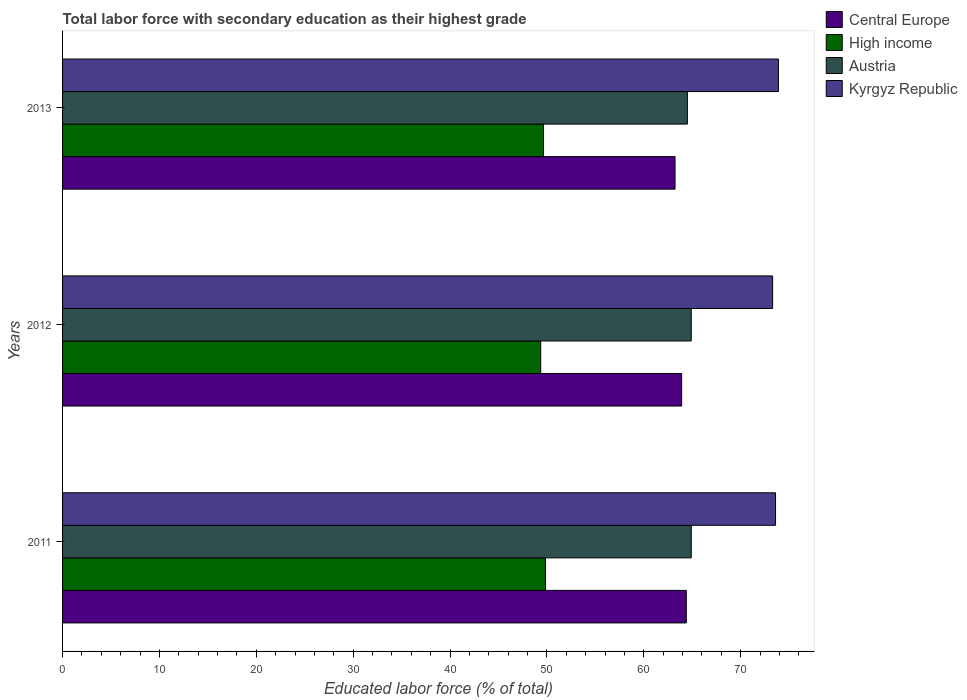How many different coloured bars are there?
Offer a very short reply. 4. How many groups of bars are there?
Make the answer very short. 3. How many bars are there on the 1st tick from the bottom?
Offer a terse response. 4. What is the label of the 3rd group of bars from the top?
Your response must be concise. 2011. What is the percentage of total labor force with primary education in High income in 2012?
Provide a succinct answer. 49.36. Across all years, what is the maximum percentage of total labor force with primary education in Austria?
Keep it short and to the point. 64.9. Across all years, what is the minimum percentage of total labor force with primary education in Kyrgyz Republic?
Ensure brevity in your answer.  73.3. In which year was the percentage of total labor force with primary education in Central Europe maximum?
Offer a very short reply. 2011. What is the total percentage of total labor force with primary education in Kyrgyz Republic in the graph?
Give a very brief answer. 220.8. What is the difference between the percentage of total labor force with primary education in Kyrgyz Republic in 2012 and that in 2013?
Make the answer very short. -0.6. What is the difference between the percentage of total labor force with primary education in Kyrgyz Republic in 2011 and the percentage of total labor force with primary education in Central Europe in 2013?
Your answer should be compact. 10.37. What is the average percentage of total labor force with primary education in Austria per year?
Your answer should be very brief. 64.77. In the year 2011, what is the difference between the percentage of total labor force with primary education in Austria and percentage of total labor force with primary education in Central Europe?
Provide a short and direct response. 0.51. What is the ratio of the percentage of total labor force with primary education in High income in 2011 to that in 2012?
Your answer should be compact. 1.01. Is the percentage of total labor force with primary education in Kyrgyz Republic in 2012 less than that in 2013?
Your answer should be compact. Yes. Is the difference between the percentage of total labor force with primary education in Austria in 2011 and 2012 greater than the difference between the percentage of total labor force with primary education in Central Europe in 2011 and 2012?
Keep it short and to the point. No. What is the difference between the highest and the lowest percentage of total labor force with primary education in Austria?
Provide a succinct answer. 0.4. In how many years, is the percentage of total labor force with primary education in Austria greater than the average percentage of total labor force with primary education in Austria taken over all years?
Provide a succinct answer. 2. Is the sum of the percentage of total labor force with primary education in Austria in 2011 and 2012 greater than the maximum percentage of total labor force with primary education in Kyrgyz Republic across all years?
Offer a very short reply. Yes. Is it the case that in every year, the sum of the percentage of total labor force with primary education in Austria and percentage of total labor force with primary education in Kyrgyz Republic is greater than the sum of percentage of total labor force with primary education in Central Europe and percentage of total labor force with primary education in High income?
Give a very brief answer. Yes. What does the 3rd bar from the top in 2013 represents?
Ensure brevity in your answer.  High income. What does the 3rd bar from the bottom in 2013 represents?
Your answer should be compact. Austria. Is it the case that in every year, the sum of the percentage of total labor force with primary education in High income and percentage of total labor force with primary education in Kyrgyz Republic is greater than the percentage of total labor force with primary education in Central Europe?
Offer a terse response. Yes. How many bars are there?
Offer a terse response. 12. Are all the bars in the graph horizontal?
Your answer should be compact. Yes. Are the values on the major ticks of X-axis written in scientific E-notation?
Your answer should be compact. No. Does the graph contain any zero values?
Offer a terse response. No. Does the graph contain grids?
Your response must be concise. No. Where does the legend appear in the graph?
Keep it short and to the point. Top right. What is the title of the graph?
Make the answer very short. Total labor force with secondary education as their highest grade. Does "Sub-Saharan Africa (developing only)" appear as one of the legend labels in the graph?
Offer a terse response. No. What is the label or title of the X-axis?
Offer a very short reply. Educated labor force (% of total). What is the label or title of the Y-axis?
Offer a very short reply. Years. What is the Educated labor force (% of total) in Central Europe in 2011?
Keep it short and to the point. 64.39. What is the Educated labor force (% of total) of High income in 2011?
Your response must be concise. 49.85. What is the Educated labor force (% of total) of Austria in 2011?
Your answer should be very brief. 64.9. What is the Educated labor force (% of total) of Kyrgyz Republic in 2011?
Ensure brevity in your answer.  73.6. What is the Educated labor force (% of total) in Central Europe in 2012?
Provide a short and direct response. 63.91. What is the Educated labor force (% of total) in High income in 2012?
Keep it short and to the point. 49.36. What is the Educated labor force (% of total) in Austria in 2012?
Provide a short and direct response. 64.9. What is the Educated labor force (% of total) of Kyrgyz Republic in 2012?
Offer a very short reply. 73.3. What is the Educated labor force (% of total) in Central Europe in 2013?
Your answer should be compact. 63.23. What is the Educated labor force (% of total) of High income in 2013?
Give a very brief answer. 49.65. What is the Educated labor force (% of total) in Austria in 2013?
Provide a succinct answer. 64.5. What is the Educated labor force (% of total) of Kyrgyz Republic in 2013?
Offer a terse response. 73.9. Across all years, what is the maximum Educated labor force (% of total) of Central Europe?
Your answer should be very brief. 64.39. Across all years, what is the maximum Educated labor force (% of total) in High income?
Give a very brief answer. 49.85. Across all years, what is the maximum Educated labor force (% of total) in Austria?
Your response must be concise. 64.9. Across all years, what is the maximum Educated labor force (% of total) of Kyrgyz Republic?
Ensure brevity in your answer.  73.9. Across all years, what is the minimum Educated labor force (% of total) of Central Europe?
Provide a succinct answer. 63.23. Across all years, what is the minimum Educated labor force (% of total) in High income?
Give a very brief answer. 49.36. Across all years, what is the minimum Educated labor force (% of total) of Austria?
Offer a terse response. 64.5. Across all years, what is the minimum Educated labor force (% of total) of Kyrgyz Republic?
Offer a terse response. 73.3. What is the total Educated labor force (% of total) in Central Europe in the graph?
Provide a succinct answer. 191.52. What is the total Educated labor force (% of total) in High income in the graph?
Provide a short and direct response. 148.86. What is the total Educated labor force (% of total) of Austria in the graph?
Provide a short and direct response. 194.3. What is the total Educated labor force (% of total) of Kyrgyz Republic in the graph?
Provide a short and direct response. 220.8. What is the difference between the Educated labor force (% of total) in Central Europe in 2011 and that in 2012?
Make the answer very short. 0.48. What is the difference between the Educated labor force (% of total) in High income in 2011 and that in 2012?
Offer a very short reply. 0.49. What is the difference between the Educated labor force (% of total) in Austria in 2011 and that in 2012?
Your response must be concise. 0. What is the difference between the Educated labor force (% of total) of Kyrgyz Republic in 2011 and that in 2012?
Provide a succinct answer. 0.3. What is the difference between the Educated labor force (% of total) of Central Europe in 2011 and that in 2013?
Keep it short and to the point. 1.16. What is the difference between the Educated labor force (% of total) in High income in 2011 and that in 2013?
Provide a succinct answer. 0.2. What is the difference between the Educated labor force (% of total) of Kyrgyz Republic in 2011 and that in 2013?
Your answer should be very brief. -0.3. What is the difference between the Educated labor force (% of total) of Central Europe in 2012 and that in 2013?
Your response must be concise. 0.68. What is the difference between the Educated labor force (% of total) of High income in 2012 and that in 2013?
Provide a short and direct response. -0.29. What is the difference between the Educated labor force (% of total) of Kyrgyz Republic in 2012 and that in 2013?
Your response must be concise. -0.6. What is the difference between the Educated labor force (% of total) in Central Europe in 2011 and the Educated labor force (% of total) in High income in 2012?
Your answer should be compact. 15.03. What is the difference between the Educated labor force (% of total) in Central Europe in 2011 and the Educated labor force (% of total) in Austria in 2012?
Your response must be concise. -0.51. What is the difference between the Educated labor force (% of total) in Central Europe in 2011 and the Educated labor force (% of total) in Kyrgyz Republic in 2012?
Offer a very short reply. -8.91. What is the difference between the Educated labor force (% of total) of High income in 2011 and the Educated labor force (% of total) of Austria in 2012?
Offer a terse response. -15.05. What is the difference between the Educated labor force (% of total) in High income in 2011 and the Educated labor force (% of total) in Kyrgyz Republic in 2012?
Give a very brief answer. -23.45. What is the difference between the Educated labor force (% of total) of Central Europe in 2011 and the Educated labor force (% of total) of High income in 2013?
Offer a terse response. 14.74. What is the difference between the Educated labor force (% of total) of Central Europe in 2011 and the Educated labor force (% of total) of Austria in 2013?
Make the answer very short. -0.11. What is the difference between the Educated labor force (% of total) of Central Europe in 2011 and the Educated labor force (% of total) of Kyrgyz Republic in 2013?
Your answer should be compact. -9.51. What is the difference between the Educated labor force (% of total) of High income in 2011 and the Educated labor force (% of total) of Austria in 2013?
Make the answer very short. -14.65. What is the difference between the Educated labor force (% of total) of High income in 2011 and the Educated labor force (% of total) of Kyrgyz Republic in 2013?
Give a very brief answer. -24.05. What is the difference between the Educated labor force (% of total) in Central Europe in 2012 and the Educated labor force (% of total) in High income in 2013?
Make the answer very short. 14.26. What is the difference between the Educated labor force (% of total) in Central Europe in 2012 and the Educated labor force (% of total) in Austria in 2013?
Your response must be concise. -0.59. What is the difference between the Educated labor force (% of total) in Central Europe in 2012 and the Educated labor force (% of total) in Kyrgyz Republic in 2013?
Your response must be concise. -9.99. What is the difference between the Educated labor force (% of total) in High income in 2012 and the Educated labor force (% of total) in Austria in 2013?
Your answer should be very brief. -15.14. What is the difference between the Educated labor force (% of total) of High income in 2012 and the Educated labor force (% of total) of Kyrgyz Republic in 2013?
Make the answer very short. -24.54. What is the difference between the Educated labor force (% of total) of Austria in 2012 and the Educated labor force (% of total) of Kyrgyz Republic in 2013?
Your answer should be very brief. -9. What is the average Educated labor force (% of total) in Central Europe per year?
Make the answer very short. 63.84. What is the average Educated labor force (% of total) of High income per year?
Provide a succinct answer. 49.62. What is the average Educated labor force (% of total) in Austria per year?
Give a very brief answer. 64.77. What is the average Educated labor force (% of total) in Kyrgyz Republic per year?
Provide a succinct answer. 73.6. In the year 2011, what is the difference between the Educated labor force (% of total) of Central Europe and Educated labor force (% of total) of High income?
Keep it short and to the point. 14.54. In the year 2011, what is the difference between the Educated labor force (% of total) of Central Europe and Educated labor force (% of total) of Austria?
Offer a very short reply. -0.51. In the year 2011, what is the difference between the Educated labor force (% of total) in Central Europe and Educated labor force (% of total) in Kyrgyz Republic?
Your answer should be very brief. -9.21. In the year 2011, what is the difference between the Educated labor force (% of total) in High income and Educated labor force (% of total) in Austria?
Make the answer very short. -15.05. In the year 2011, what is the difference between the Educated labor force (% of total) of High income and Educated labor force (% of total) of Kyrgyz Republic?
Your answer should be very brief. -23.75. In the year 2012, what is the difference between the Educated labor force (% of total) of Central Europe and Educated labor force (% of total) of High income?
Provide a succinct answer. 14.55. In the year 2012, what is the difference between the Educated labor force (% of total) of Central Europe and Educated labor force (% of total) of Austria?
Offer a very short reply. -0.99. In the year 2012, what is the difference between the Educated labor force (% of total) in Central Europe and Educated labor force (% of total) in Kyrgyz Republic?
Provide a short and direct response. -9.39. In the year 2012, what is the difference between the Educated labor force (% of total) of High income and Educated labor force (% of total) of Austria?
Ensure brevity in your answer.  -15.54. In the year 2012, what is the difference between the Educated labor force (% of total) of High income and Educated labor force (% of total) of Kyrgyz Republic?
Your answer should be compact. -23.94. In the year 2012, what is the difference between the Educated labor force (% of total) in Austria and Educated labor force (% of total) in Kyrgyz Republic?
Provide a short and direct response. -8.4. In the year 2013, what is the difference between the Educated labor force (% of total) in Central Europe and Educated labor force (% of total) in High income?
Your answer should be very brief. 13.58. In the year 2013, what is the difference between the Educated labor force (% of total) in Central Europe and Educated labor force (% of total) in Austria?
Provide a short and direct response. -1.27. In the year 2013, what is the difference between the Educated labor force (% of total) in Central Europe and Educated labor force (% of total) in Kyrgyz Republic?
Provide a short and direct response. -10.67. In the year 2013, what is the difference between the Educated labor force (% of total) of High income and Educated labor force (% of total) of Austria?
Make the answer very short. -14.85. In the year 2013, what is the difference between the Educated labor force (% of total) of High income and Educated labor force (% of total) of Kyrgyz Republic?
Keep it short and to the point. -24.25. What is the ratio of the Educated labor force (% of total) of Central Europe in 2011 to that in 2012?
Your answer should be compact. 1.01. What is the ratio of the Educated labor force (% of total) of High income in 2011 to that in 2012?
Offer a terse response. 1.01. What is the ratio of the Educated labor force (% of total) in Kyrgyz Republic in 2011 to that in 2012?
Make the answer very short. 1. What is the ratio of the Educated labor force (% of total) in Central Europe in 2011 to that in 2013?
Provide a succinct answer. 1.02. What is the ratio of the Educated labor force (% of total) in Austria in 2011 to that in 2013?
Make the answer very short. 1.01. What is the ratio of the Educated labor force (% of total) of Central Europe in 2012 to that in 2013?
Keep it short and to the point. 1.01. What is the ratio of the Educated labor force (% of total) of High income in 2012 to that in 2013?
Offer a very short reply. 0.99. What is the ratio of the Educated labor force (% of total) in Austria in 2012 to that in 2013?
Offer a very short reply. 1.01. What is the ratio of the Educated labor force (% of total) in Kyrgyz Republic in 2012 to that in 2013?
Your answer should be very brief. 0.99. What is the difference between the highest and the second highest Educated labor force (% of total) in Central Europe?
Offer a terse response. 0.48. What is the difference between the highest and the second highest Educated labor force (% of total) of High income?
Your answer should be compact. 0.2. What is the difference between the highest and the second highest Educated labor force (% of total) in Austria?
Your response must be concise. 0. What is the difference between the highest and the lowest Educated labor force (% of total) of Central Europe?
Keep it short and to the point. 1.16. What is the difference between the highest and the lowest Educated labor force (% of total) in High income?
Your response must be concise. 0.49. What is the difference between the highest and the lowest Educated labor force (% of total) of Kyrgyz Republic?
Your answer should be very brief. 0.6. 